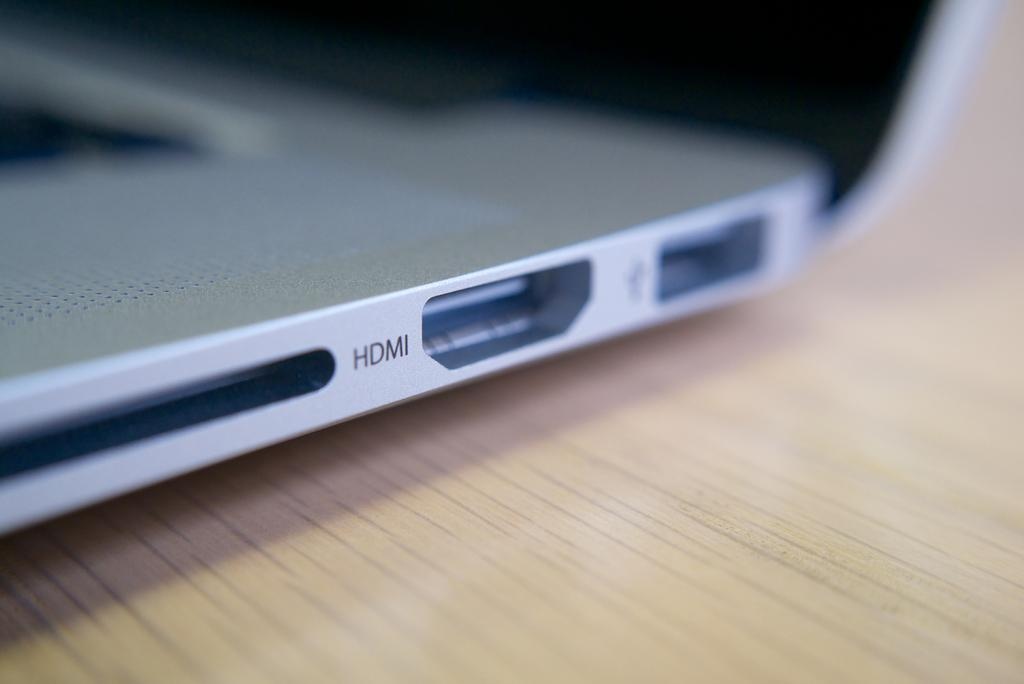<image>
Create a compact narrative representing the image presented. A closeup of the side of a laptop with the word HDMI 